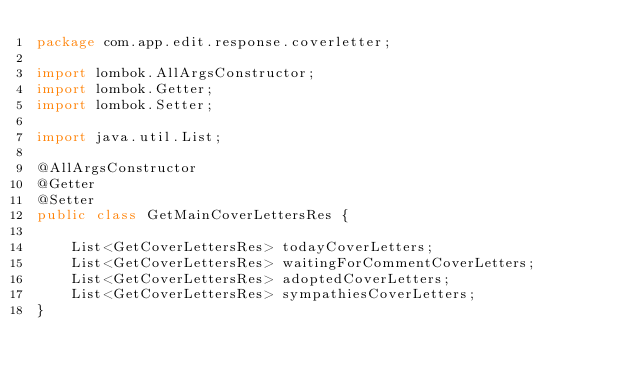<code> <loc_0><loc_0><loc_500><loc_500><_Java_>package com.app.edit.response.coverletter;

import lombok.AllArgsConstructor;
import lombok.Getter;
import lombok.Setter;

import java.util.List;

@AllArgsConstructor
@Getter
@Setter
public class GetMainCoverLettersRes {

    List<GetCoverLettersRes> todayCoverLetters;
    List<GetCoverLettersRes> waitingForCommentCoverLetters;
    List<GetCoverLettersRes> adoptedCoverLetters;
    List<GetCoverLettersRes> sympathiesCoverLetters;
}
</code> 